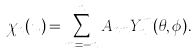<formula> <loc_0><loc_0><loc_500><loc_500>\chi _ { n } ( u ) = \sum _ { m = - n } ^ { n } A _ { n m } Y _ { n } ^ { m } ( \theta , \phi ) .</formula> 